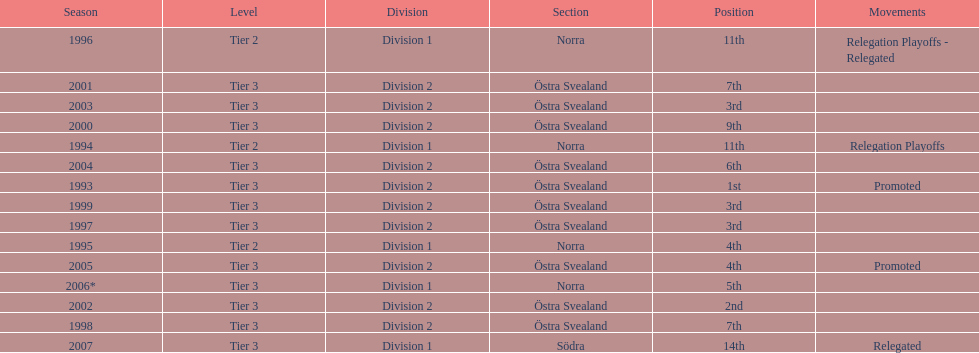What are the number of times norra was listed as the section? 4. 